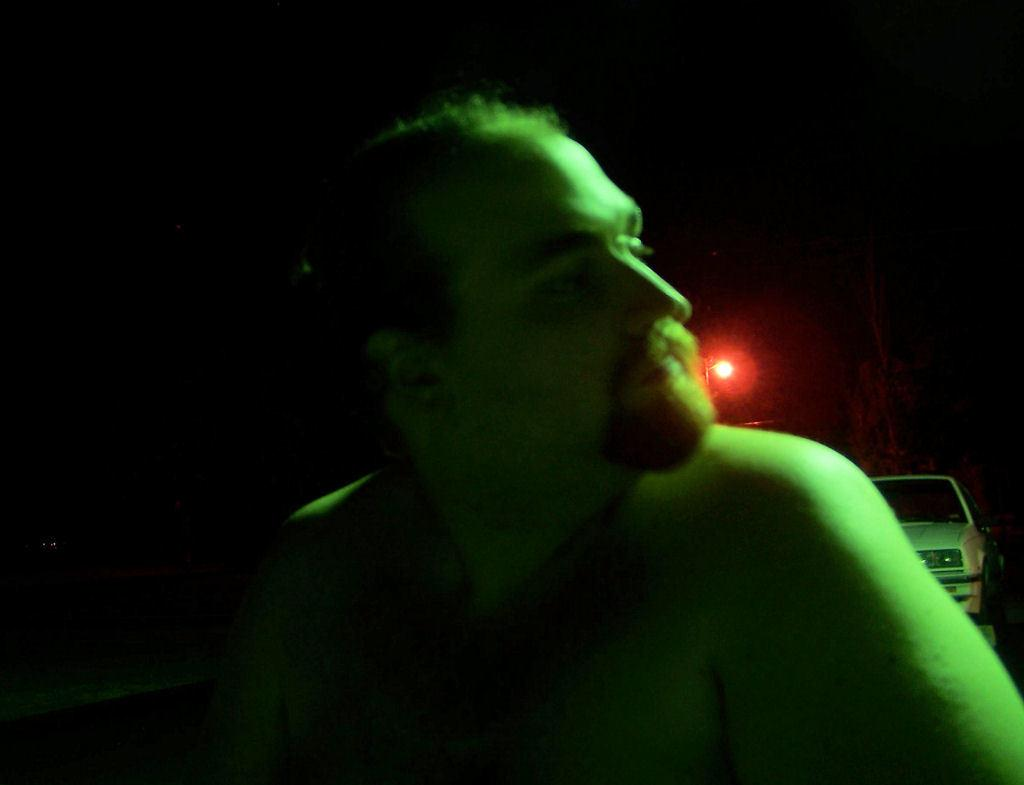Who is present in the image? There is a man in the image. What can be seen in the background of the image? There is a car and a light in the background of the image. How would you describe the lighting conditions in the image? The environment in the image is dark. How many chairs are visible in the image? There are no chairs present in the image. What type of machine is being used by the man in the image? There is no machine visible in the image; the man is not interacting with any machinery. 